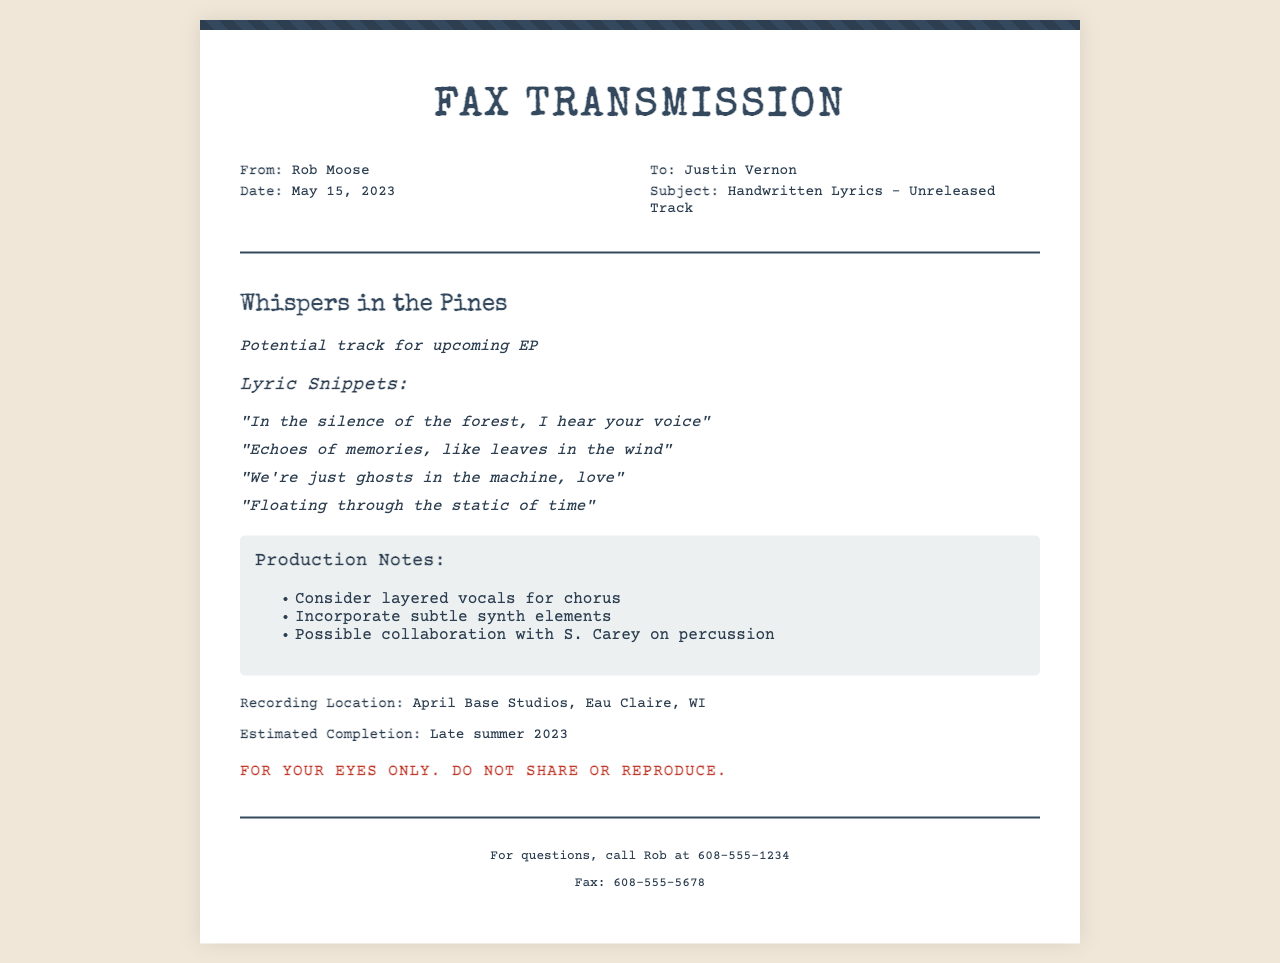What is the title of the song? The title of the song is mentioned in the document, which is "Whispers in the Pines."
Answer: Whispers in the Pines Who is the sender of the fax? The sender of the fax is Rob Moose, as indicated in the document.
Answer: Rob Moose What is the date of the fax? The date of the fax is specifically stated in the document as May 15, 2023.
Answer: May 15, 2023 Where is the recording location stated in the fax? The document notes that the recording location is April Base Studios, Eau Claire, WI.
Answer: April Base Studios, Eau Claire, WI What is the estimated completion date for the track? The estimated completion date is mentioned as late summer 2023.
Answer: Late summer 2023 What collaboration is suggested in the production notes? The document suggests a possible collaboration with S. Carey on percussion.
Answer: S. Carey What is one lyric snippet included in the fax? The document includes various lyric snippets, one of which is "In the silence of the forest, I hear your voice."
Answer: "In the silence of the forest, I hear your voice" What are the potential elements to consider for the chorus? The production notes mention considering layered vocals for the chorus.
Answer: Layered vocals Is this document meant to be shared widely? The document includes a statement indicating that it is confidential and for the recipient's eyes only.
Answer: No 